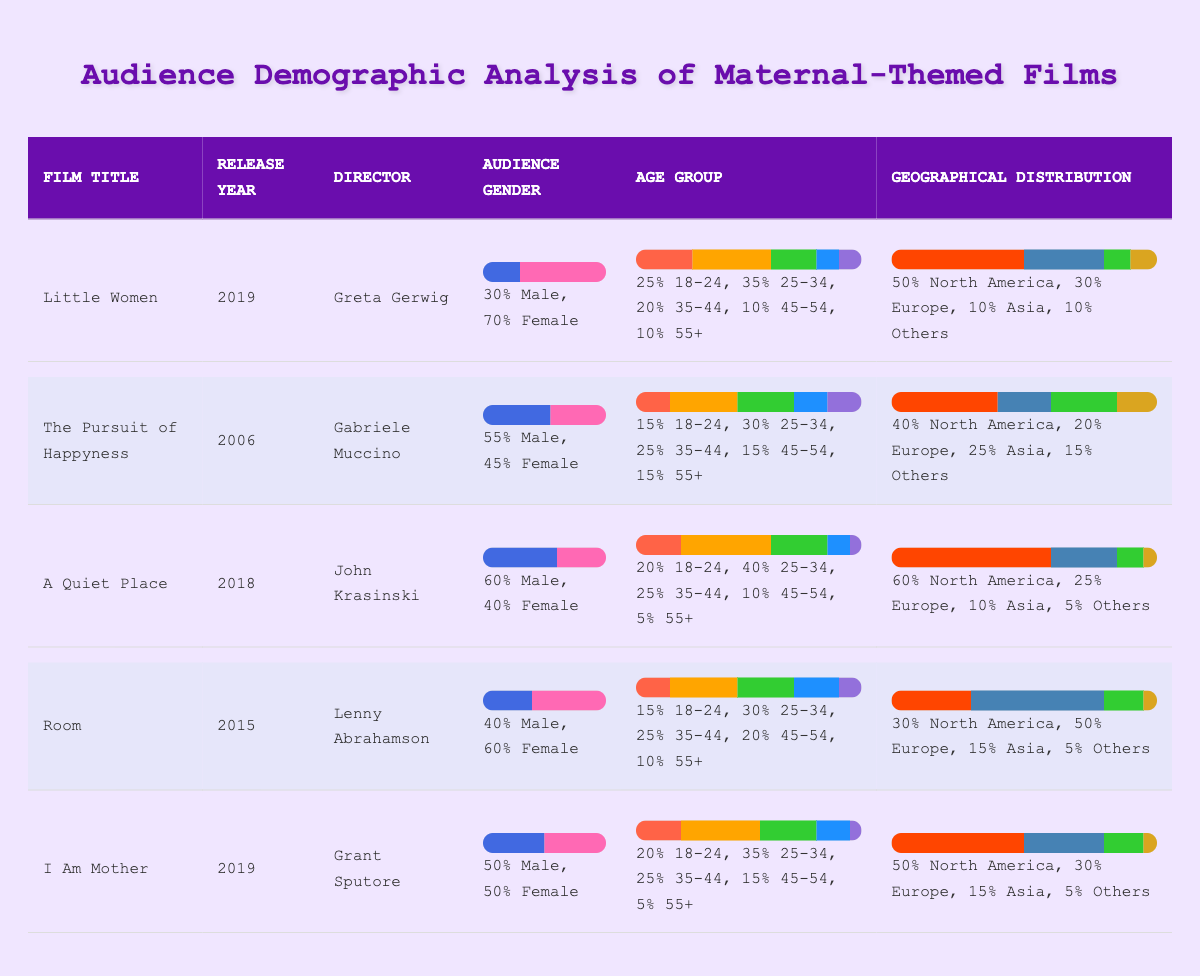What percentage of the audience for "Little Women" is female? The gender distribution for "Little Women" shows that 70% of the audience is female.
Answer: 70% Which film has the highest percentage of viewers aged 25-34? "A Quiet Place" has the highest percentage of viewers aged 25-34 at 40%.
Answer: 40% What is the total percentage of male viewers across all films listed? The total percentage of male viewers for each film is 30% (Little Women) + 55% (The Pursuit of Happyness) + 60% (A Quiet Place) + 40% (Room) + 50% (I Am Mother) = 235%. To find the average, we divide by 5 (number of films) which gives 235/5 = 47%.
Answer: 47% Is the majority of the audience for "The Pursuit of Happyness" male? Yes, "The Pursuit of Happyness" has 55% male viewers, which is the majority.
Answer: Yes What is the average percentage of female viewers across all films analyzed? To find the average percentage of female viewers, we sum the female percentages: 70% (Little Women) + 45% (The Pursuit of Happyness) + 40% (A Quiet Place) + 60% (Room) + 50% (I Am Mother) = 265%. Dividing by 5 gives us 265/5 = 53%.
Answer: 53% Which age group has the lowest percentage of viewers in "Room"? The age group 55+ has the lowest percentage of viewers in "Room" at 10%.
Answer: 10% Which film had the highest audience in North America? "A Quiet Place" had the highest audience in North America with 60%.
Answer: 60% What percentage of viewers in "I Am Mother" are aged 45-54? The audience aged 45-54 in "I Am Mother" is 15%.
Answer: 15% 